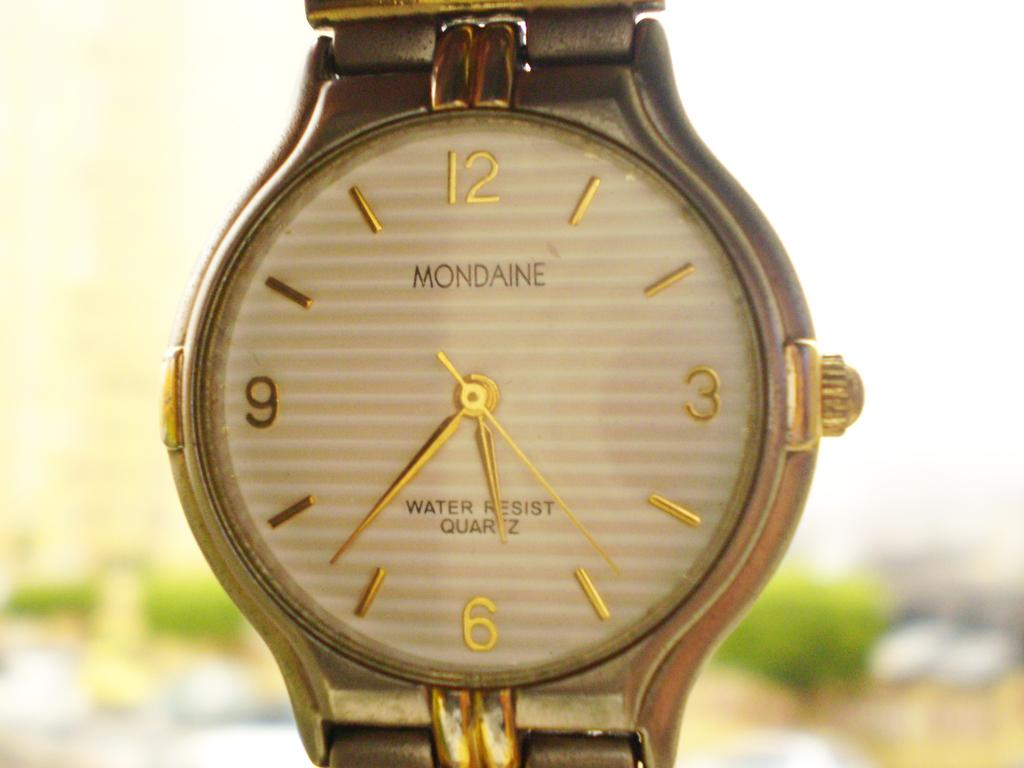<image>
Give a short and clear explanation of the subsequent image. Mondaine watch that says 5:37 and has the text that says Water Resist Quartz. 